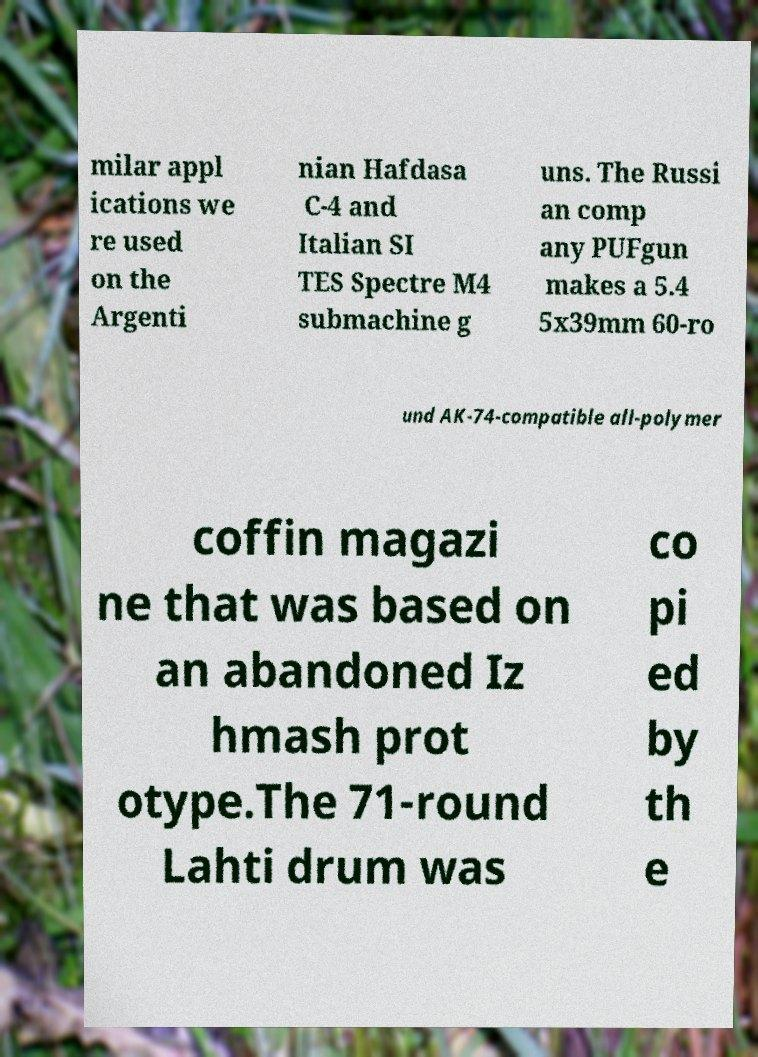Can you read and provide the text displayed in the image?This photo seems to have some interesting text. Can you extract and type it out for me? milar appl ications we re used on the Argenti nian Hafdasa C-4 and Italian SI TES Spectre M4 submachine g uns. The Russi an comp any PUFgun makes a 5.4 5x39mm 60-ro und AK-74-compatible all-polymer coffin magazi ne that was based on an abandoned Iz hmash prot otype.The 71-round Lahti drum was co pi ed by th e 